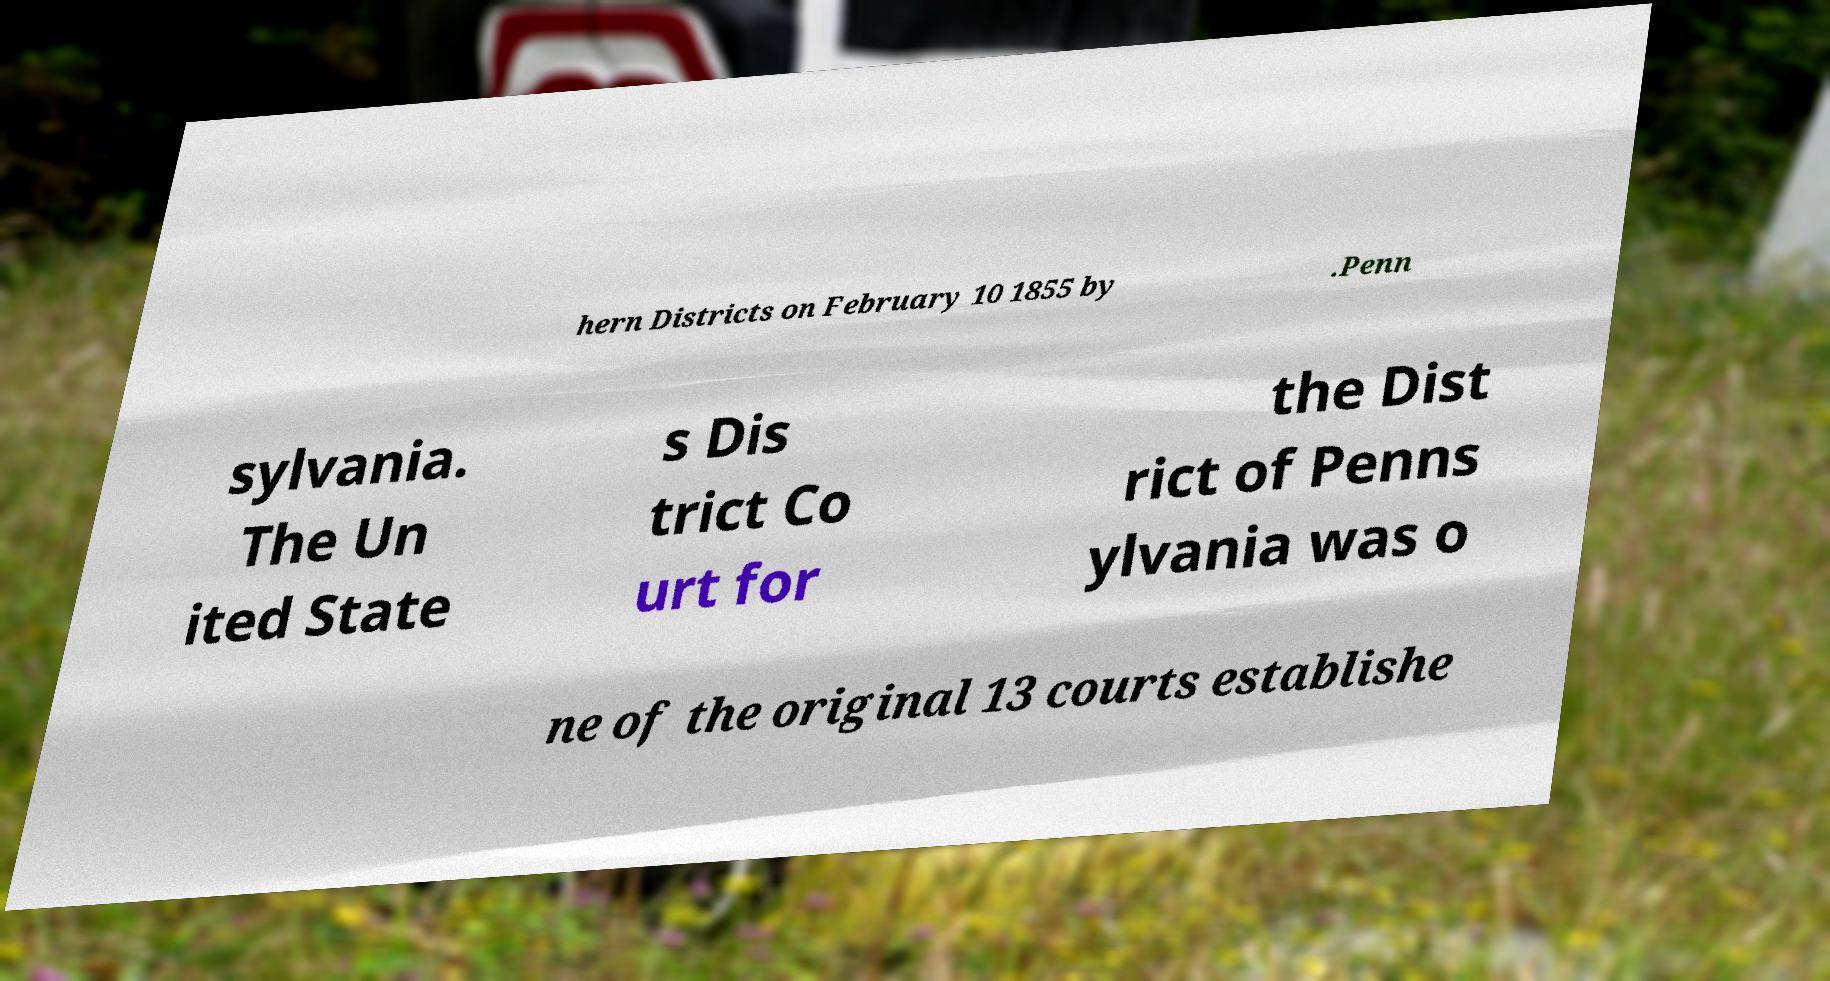Could you assist in decoding the text presented in this image and type it out clearly? hern Districts on February 10 1855 by .Penn sylvania. The Un ited State s Dis trict Co urt for the Dist rict of Penns ylvania was o ne of the original 13 courts establishe 